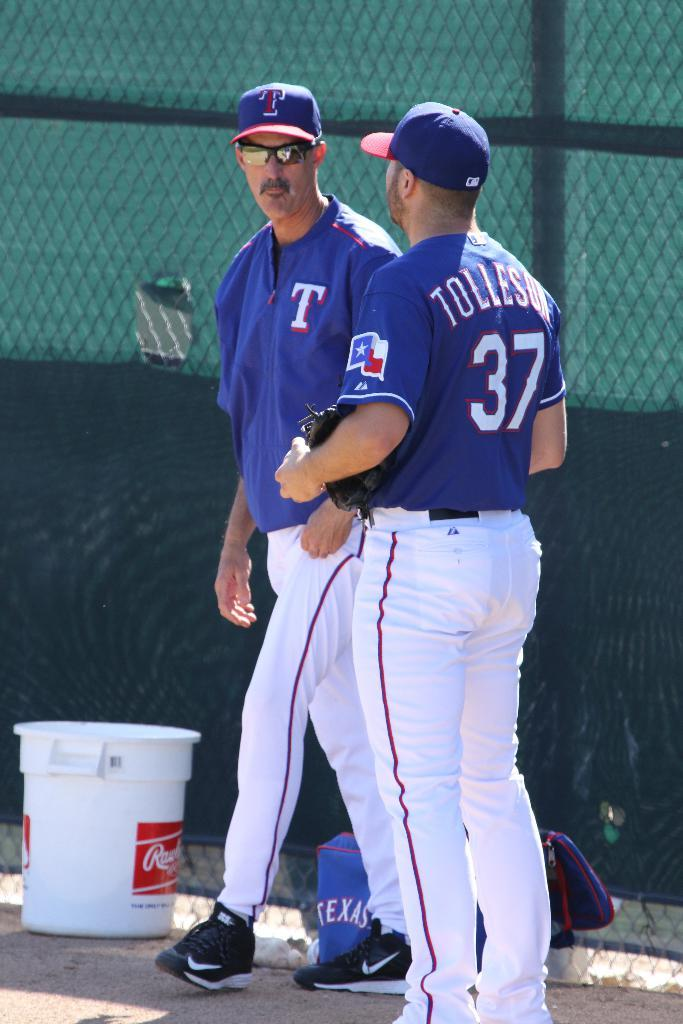Provide a one-sentence caption for the provided image. A Tolleson baseball player wearing number 37 on his jersey, is standing to the side of the field, talking to another member of the team. 